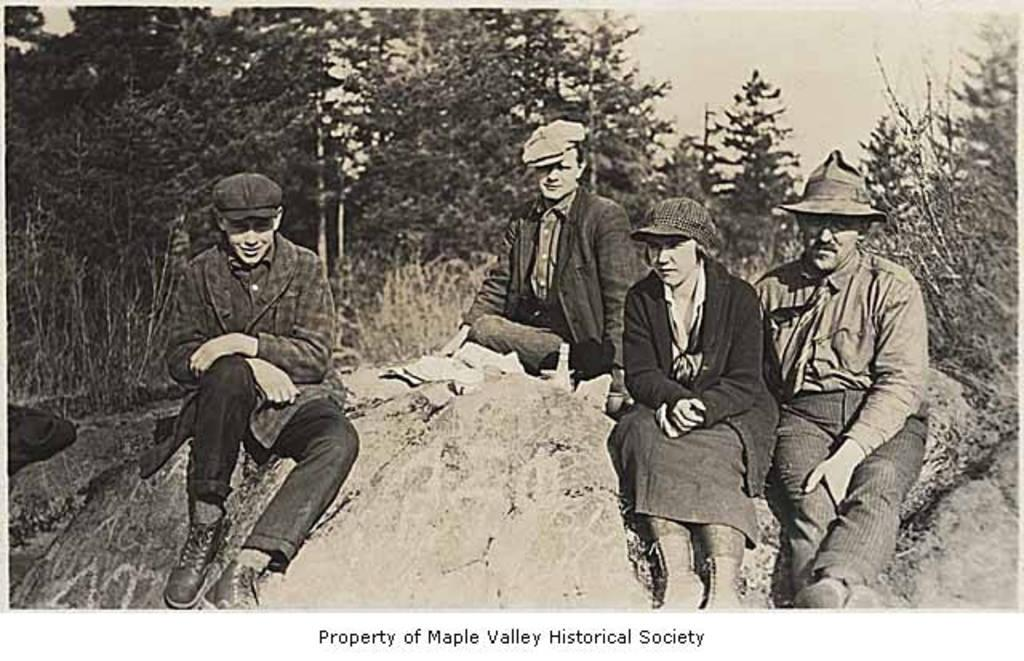What is the main subject of the image? There is a photo in the image. What can be seen in the photo? The photo contains people sitting. What type of natural environment is visible in the image? There are trees visible in the image. What is visible in the background of the image? The sky is visible in the image. What type of cheese can be seen in the aftermath of the event in the image? There is no cheese or event present in the image; it features a photo of people sitting with trees and the sky visible in the background. 